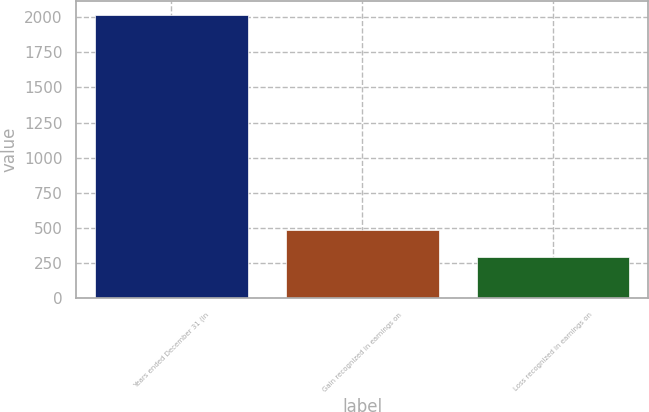<chart> <loc_0><loc_0><loc_500><loc_500><bar_chart><fcel>Years ended December 31 (in<fcel>Gain recognized in earnings on<fcel>Loss recognized in earnings on<nl><fcel>2013<fcel>484.2<fcel>293.1<nl></chart> 